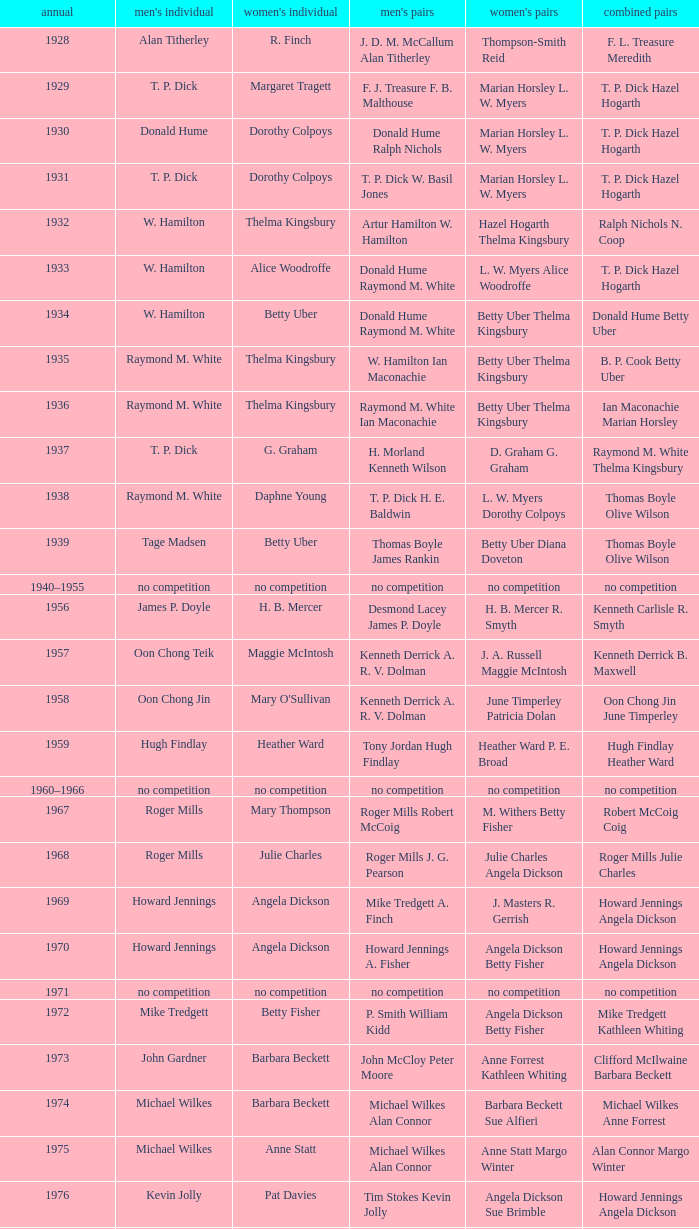Who won the Women's doubles in the year that Billy Gilliland Karen Puttick won the Mixed doubles? Jane Webster Karen Puttick. 